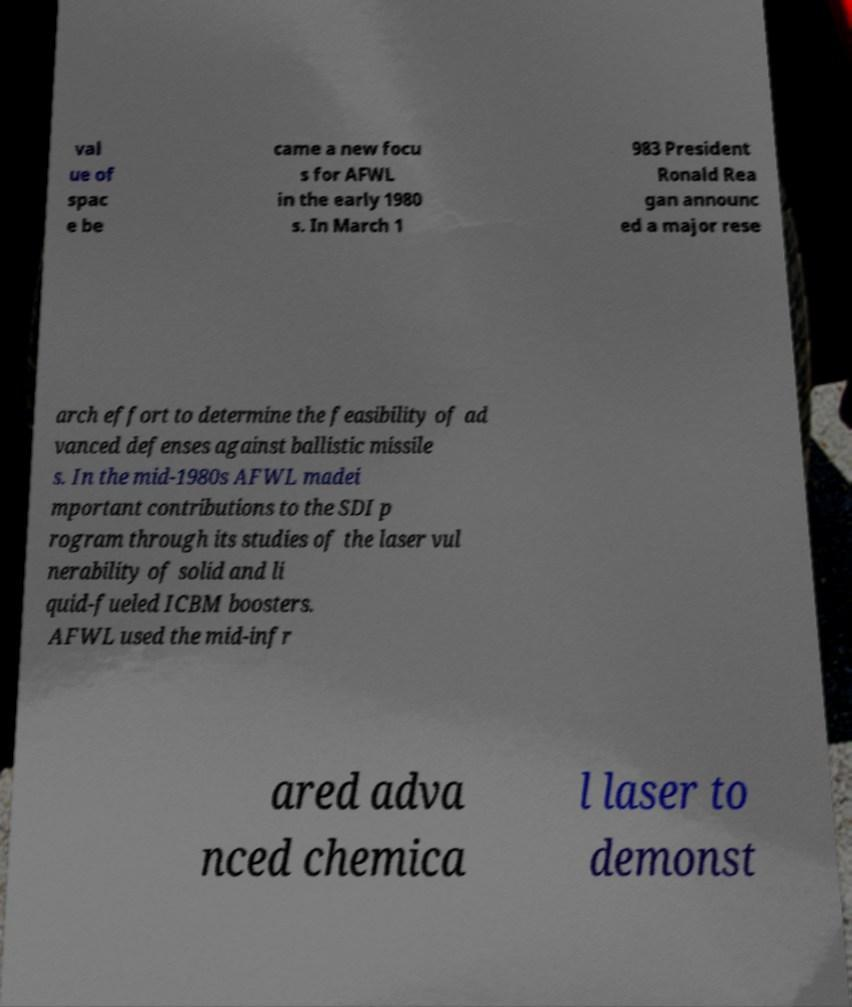There's text embedded in this image that I need extracted. Can you transcribe it verbatim? val ue of spac e be came a new focu s for AFWL in the early 1980 s. In March 1 983 President Ronald Rea gan announc ed a major rese arch effort to determine the feasibility of ad vanced defenses against ballistic missile s. In the mid-1980s AFWL madei mportant contributions to the SDI p rogram through its studies of the laser vul nerability of solid and li quid-fueled ICBM boosters. AFWL used the mid-infr ared adva nced chemica l laser to demonst 